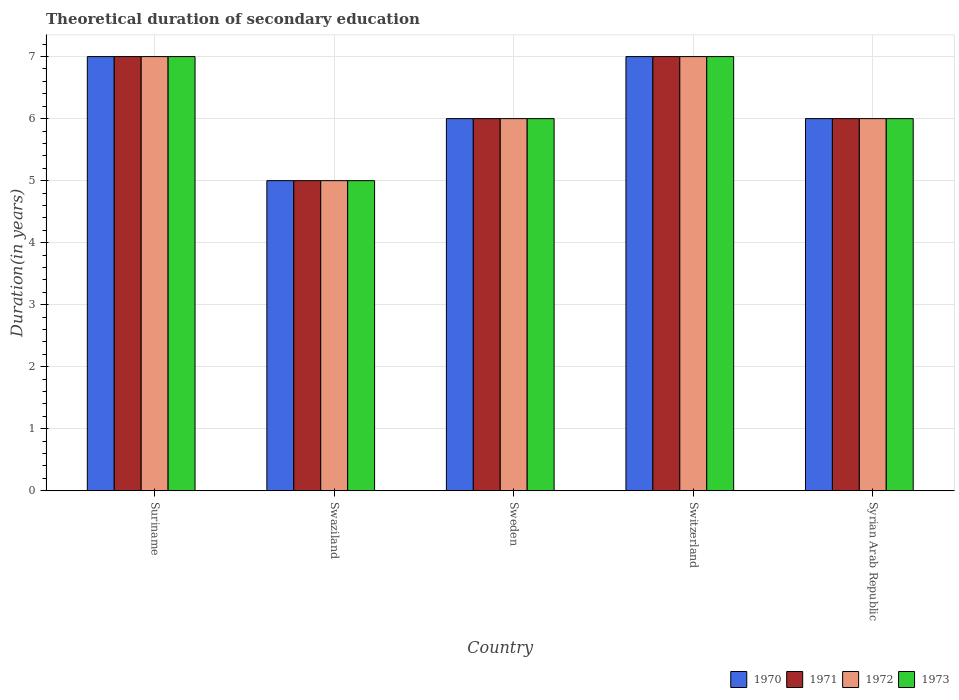How many different coloured bars are there?
Provide a succinct answer. 4. Are the number of bars on each tick of the X-axis equal?
Your response must be concise. Yes. How many bars are there on the 4th tick from the left?
Ensure brevity in your answer.  4. How many bars are there on the 4th tick from the right?
Ensure brevity in your answer.  4. Across all countries, what is the minimum total theoretical duration of secondary education in 1970?
Offer a very short reply. 5. In which country was the total theoretical duration of secondary education in 1970 maximum?
Offer a terse response. Suriname. In which country was the total theoretical duration of secondary education in 1973 minimum?
Your answer should be compact. Swaziland. What is the total total theoretical duration of secondary education in 1973 in the graph?
Provide a succinct answer. 31. What is the average total theoretical duration of secondary education in 1972 per country?
Offer a terse response. 6.2. In how many countries, is the total theoretical duration of secondary education in 1972 greater than 2.4 years?
Offer a terse response. 5. What is the ratio of the total theoretical duration of secondary education in 1971 in Swaziland to that in Sweden?
Provide a succinct answer. 0.83. What is the difference between the highest and the second highest total theoretical duration of secondary education in 1972?
Your answer should be compact. -1. What is the difference between the highest and the lowest total theoretical duration of secondary education in 1972?
Provide a succinct answer. 2. Is the sum of the total theoretical duration of secondary education in 1970 in Sweden and Syrian Arab Republic greater than the maximum total theoretical duration of secondary education in 1972 across all countries?
Ensure brevity in your answer.  Yes. Is it the case that in every country, the sum of the total theoretical duration of secondary education in 1973 and total theoretical duration of secondary education in 1972 is greater than the sum of total theoretical duration of secondary education in 1970 and total theoretical duration of secondary education in 1971?
Ensure brevity in your answer.  No. Are all the bars in the graph horizontal?
Give a very brief answer. No. How many countries are there in the graph?
Make the answer very short. 5. Does the graph contain any zero values?
Your answer should be compact. No. Where does the legend appear in the graph?
Your answer should be very brief. Bottom right. How many legend labels are there?
Ensure brevity in your answer.  4. What is the title of the graph?
Provide a succinct answer. Theoretical duration of secondary education. Does "1973" appear as one of the legend labels in the graph?
Offer a terse response. Yes. What is the label or title of the Y-axis?
Your answer should be very brief. Duration(in years). What is the Duration(in years) of 1971 in Suriname?
Your response must be concise. 7. What is the Duration(in years) in 1972 in Suriname?
Offer a terse response. 7. What is the Duration(in years) of 1973 in Suriname?
Your response must be concise. 7. What is the Duration(in years) in 1970 in Swaziland?
Give a very brief answer. 5. What is the Duration(in years) of 1971 in Swaziland?
Make the answer very short. 5. What is the Duration(in years) of 1970 in Sweden?
Your answer should be compact. 6. What is the Duration(in years) of 1971 in Sweden?
Keep it short and to the point. 6. What is the Duration(in years) in 1973 in Sweden?
Make the answer very short. 6. What is the Duration(in years) in 1970 in Switzerland?
Provide a succinct answer. 7. What is the Duration(in years) in 1971 in Switzerland?
Your response must be concise. 7. What is the Duration(in years) of 1971 in Syrian Arab Republic?
Offer a very short reply. 6. What is the Duration(in years) of 1972 in Syrian Arab Republic?
Your answer should be compact. 6. Across all countries, what is the maximum Duration(in years) of 1970?
Keep it short and to the point. 7. Across all countries, what is the maximum Duration(in years) in 1971?
Ensure brevity in your answer.  7. Across all countries, what is the maximum Duration(in years) in 1972?
Keep it short and to the point. 7. Across all countries, what is the maximum Duration(in years) in 1973?
Your answer should be compact. 7. Across all countries, what is the minimum Duration(in years) in 1970?
Ensure brevity in your answer.  5. What is the total Duration(in years) in 1971 in the graph?
Give a very brief answer. 31. What is the total Duration(in years) in 1973 in the graph?
Give a very brief answer. 31. What is the difference between the Duration(in years) in 1971 in Suriname and that in Swaziland?
Your response must be concise. 2. What is the difference between the Duration(in years) in 1972 in Suriname and that in Swaziland?
Your response must be concise. 2. What is the difference between the Duration(in years) of 1973 in Suriname and that in Swaziland?
Provide a short and direct response. 2. What is the difference between the Duration(in years) of 1970 in Suriname and that in Sweden?
Ensure brevity in your answer.  1. What is the difference between the Duration(in years) in 1972 in Suriname and that in Sweden?
Ensure brevity in your answer.  1. What is the difference between the Duration(in years) in 1973 in Suriname and that in Switzerland?
Provide a short and direct response. 0. What is the difference between the Duration(in years) in 1970 in Suriname and that in Syrian Arab Republic?
Your response must be concise. 1. What is the difference between the Duration(in years) of 1970 in Swaziland and that in Sweden?
Offer a terse response. -1. What is the difference between the Duration(in years) of 1971 in Swaziland and that in Sweden?
Keep it short and to the point. -1. What is the difference between the Duration(in years) of 1972 in Swaziland and that in Sweden?
Give a very brief answer. -1. What is the difference between the Duration(in years) of 1973 in Swaziland and that in Sweden?
Provide a succinct answer. -1. What is the difference between the Duration(in years) of 1970 in Swaziland and that in Switzerland?
Offer a terse response. -2. What is the difference between the Duration(in years) of 1971 in Swaziland and that in Switzerland?
Provide a short and direct response. -2. What is the difference between the Duration(in years) in 1973 in Swaziland and that in Switzerland?
Make the answer very short. -2. What is the difference between the Duration(in years) in 1970 in Swaziland and that in Syrian Arab Republic?
Give a very brief answer. -1. What is the difference between the Duration(in years) of 1972 in Swaziland and that in Syrian Arab Republic?
Keep it short and to the point. -1. What is the difference between the Duration(in years) of 1973 in Swaziland and that in Syrian Arab Republic?
Offer a terse response. -1. What is the difference between the Duration(in years) in 1972 in Sweden and that in Switzerland?
Give a very brief answer. -1. What is the difference between the Duration(in years) of 1971 in Sweden and that in Syrian Arab Republic?
Keep it short and to the point. 0. What is the difference between the Duration(in years) of 1970 in Switzerland and that in Syrian Arab Republic?
Provide a succinct answer. 1. What is the difference between the Duration(in years) in 1971 in Switzerland and that in Syrian Arab Republic?
Provide a short and direct response. 1. What is the difference between the Duration(in years) in 1972 in Switzerland and that in Syrian Arab Republic?
Provide a succinct answer. 1. What is the difference between the Duration(in years) of 1970 in Suriname and the Duration(in years) of 1972 in Swaziland?
Offer a terse response. 2. What is the difference between the Duration(in years) of 1970 in Suriname and the Duration(in years) of 1973 in Swaziland?
Make the answer very short. 2. What is the difference between the Duration(in years) in 1970 in Suriname and the Duration(in years) in 1972 in Sweden?
Your answer should be compact. 1. What is the difference between the Duration(in years) of 1970 in Suriname and the Duration(in years) of 1973 in Sweden?
Your answer should be very brief. 1. What is the difference between the Duration(in years) of 1970 in Suriname and the Duration(in years) of 1972 in Switzerland?
Ensure brevity in your answer.  0. What is the difference between the Duration(in years) of 1971 in Suriname and the Duration(in years) of 1973 in Switzerland?
Provide a short and direct response. 0. What is the difference between the Duration(in years) in 1972 in Suriname and the Duration(in years) in 1973 in Switzerland?
Keep it short and to the point. 0. What is the difference between the Duration(in years) in 1970 in Suriname and the Duration(in years) in 1971 in Syrian Arab Republic?
Offer a very short reply. 1. What is the difference between the Duration(in years) of 1970 in Suriname and the Duration(in years) of 1972 in Syrian Arab Republic?
Provide a succinct answer. 1. What is the difference between the Duration(in years) of 1970 in Suriname and the Duration(in years) of 1973 in Syrian Arab Republic?
Provide a succinct answer. 1. What is the difference between the Duration(in years) in 1970 in Swaziland and the Duration(in years) in 1971 in Sweden?
Make the answer very short. -1. What is the difference between the Duration(in years) of 1970 in Swaziland and the Duration(in years) of 1972 in Sweden?
Offer a terse response. -1. What is the difference between the Duration(in years) in 1971 in Swaziland and the Duration(in years) in 1972 in Sweden?
Your response must be concise. -1. What is the difference between the Duration(in years) of 1970 in Swaziland and the Duration(in years) of 1972 in Switzerland?
Give a very brief answer. -2. What is the difference between the Duration(in years) of 1970 in Swaziland and the Duration(in years) of 1973 in Switzerland?
Ensure brevity in your answer.  -2. What is the difference between the Duration(in years) in 1971 in Swaziland and the Duration(in years) in 1972 in Switzerland?
Give a very brief answer. -2. What is the difference between the Duration(in years) of 1972 in Swaziland and the Duration(in years) of 1973 in Switzerland?
Offer a terse response. -2. What is the difference between the Duration(in years) in 1970 in Swaziland and the Duration(in years) in 1972 in Syrian Arab Republic?
Your answer should be very brief. -1. What is the difference between the Duration(in years) of 1971 in Swaziland and the Duration(in years) of 1973 in Syrian Arab Republic?
Ensure brevity in your answer.  -1. What is the difference between the Duration(in years) in 1972 in Swaziland and the Duration(in years) in 1973 in Syrian Arab Republic?
Your answer should be very brief. -1. What is the difference between the Duration(in years) in 1970 in Sweden and the Duration(in years) in 1972 in Switzerland?
Provide a short and direct response. -1. What is the difference between the Duration(in years) in 1971 in Sweden and the Duration(in years) in 1972 in Switzerland?
Provide a short and direct response. -1. What is the difference between the Duration(in years) in 1970 in Sweden and the Duration(in years) in 1971 in Syrian Arab Republic?
Offer a terse response. 0. What is the difference between the Duration(in years) of 1971 in Sweden and the Duration(in years) of 1972 in Syrian Arab Republic?
Ensure brevity in your answer.  0. What is the difference between the Duration(in years) in 1971 in Sweden and the Duration(in years) in 1973 in Syrian Arab Republic?
Provide a short and direct response. 0. What is the difference between the Duration(in years) in 1972 in Sweden and the Duration(in years) in 1973 in Syrian Arab Republic?
Provide a short and direct response. 0. What is the difference between the Duration(in years) in 1970 in Switzerland and the Duration(in years) in 1973 in Syrian Arab Republic?
Your response must be concise. 1. What is the difference between the Duration(in years) in 1971 in Switzerland and the Duration(in years) in 1972 in Syrian Arab Republic?
Ensure brevity in your answer.  1. What is the difference between the Duration(in years) in 1972 in Switzerland and the Duration(in years) in 1973 in Syrian Arab Republic?
Provide a short and direct response. 1. What is the average Duration(in years) of 1970 per country?
Your answer should be very brief. 6.2. What is the difference between the Duration(in years) in 1970 and Duration(in years) in 1971 in Suriname?
Your answer should be very brief. 0. What is the difference between the Duration(in years) in 1970 and Duration(in years) in 1972 in Suriname?
Your response must be concise. 0. What is the difference between the Duration(in years) in 1971 and Duration(in years) in 1972 in Suriname?
Your answer should be compact. 0. What is the difference between the Duration(in years) of 1970 and Duration(in years) of 1971 in Swaziland?
Your answer should be very brief. 0. What is the difference between the Duration(in years) in 1970 and Duration(in years) in 1973 in Swaziland?
Your answer should be very brief. 0. What is the difference between the Duration(in years) in 1971 and Duration(in years) in 1972 in Swaziland?
Your answer should be compact. 0. What is the difference between the Duration(in years) in 1971 and Duration(in years) in 1973 in Swaziland?
Keep it short and to the point. 0. What is the difference between the Duration(in years) in 1970 and Duration(in years) in 1971 in Sweden?
Give a very brief answer. 0. What is the difference between the Duration(in years) of 1970 and Duration(in years) of 1972 in Sweden?
Keep it short and to the point. 0. What is the difference between the Duration(in years) in 1970 and Duration(in years) in 1973 in Sweden?
Give a very brief answer. 0. What is the difference between the Duration(in years) of 1971 and Duration(in years) of 1972 in Sweden?
Ensure brevity in your answer.  0. What is the difference between the Duration(in years) in 1970 and Duration(in years) in 1973 in Switzerland?
Keep it short and to the point. 0. What is the difference between the Duration(in years) in 1971 and Duration(in years) in 1972 in Switzerland?
Give a very brief answer. 0. What is the difference between the Duration(in years) in 1971 and Duration(in years) in 1973 in Switzerland?
Offer a terse response. 0. What is the difference between the Duration(in years) in 1972 and Duration(in years) in 1973 in Switzerland?
Your answer should be compact. 0. What is the difference between the Duration(in years) in 1970 and Duration(in years) in 1973 in Syrian Arab Republic?
Offer a terse response. 0. What is the difference between the Duration(in years) of 1971 and Duration(in years) of 1972 in Syrian Arab Republic?
Your response must be concise. 0. What is the difference between the Duration(in years) of 1971 and Duration(in years) of 1973 in Syrian Arab Republic?
Provide a succinct answer. 0. What is the difference between the Duration(in years) in 1972 and Duration(in years) in 1973 in Syrian Arab Republic?
Provide a short and direct response. 0. What is the ratio of the Duration(in years) in 1972 in Suriname to that in Swaziland?
Your answer should be compact. 1.4. What is the ratio of the Duration(in years) of 1972 in Suriname to that in Sweden?
Your answer should be very brief. 1.17. What is the ratio of the Duration(in years) of 1973 in Suriname to that in Sweden?
Provide a short and direct response. 1.17. What is the ratio of the Duration(in years) in 1970 in Suriname to that in Switzerland?
Your answer should be compact. 1. What is the ratio of the Duration(in years) of 1970 in Suriname to that in Syrian Arab Republic?
Provide a succinct answer. 1.17. What is the ratio of the Duration(in years) in 1970 in Swaziland to that in Sweden?
Your answer should be compact. 0.83. What is the ratio of the Duration(in years) of 1971 in Swaziland to that in Switzerland?
Ensure brevity in your answer.  0.71. What is the ratio of the Duration(in years) in 1972 in Swaziland to that in Switzerland?
Give a very brief answer. 0.71. What is the ratio of the Duration(in years) in 1970 in Swaziland to that in Syrian Arab Republic?
Your answer should be very brief. 0.83. What is the ratio of the Duration(in years) of 1973 in Swaziland to that in Syrian Arab Republic?
Offer a terse response. 0.83. What is the ratio of the Duration(in years) of 1972 in Sweden to that in Switzerland?
Your answer should be compact. 0.86. What is the ratio of the Duration(in years) of 1973 in Sweden to that in Switzerland?
Keep it short and to the point. 0.86. What is the ratio of the Duration(in years) of 1970 in Sweden to that in Syrian Arab Republic?
Your response must be concise. 1. What is the ratio of the Duration(in years) in 1973 in Sweden to that in Syrian Arab Republic?
Provide a succinct answer. 1. What is the ratio of the Duration(in years) in 1970 in Switzerland to that in Syrian Arab Republic?
Offer a very short reply. 1.17. What is the ratio of the Duration(in years) of 1971 in Switzerland to that in Syrian Arab Republic?
Provide a succinct answer. 1.17. What is the ratio of the Duration(in years) of 1972 in Switzerland to that in Syrian Arab Republic?
Your response must be concise. 1.17. What is the ratio of the Duration(in years) in 1973 in Switzerland to that in Syrian Arab Republic?
Offer a terse response. 1.17. What is the difference between the highest and the second highest Duration(in years) in 1972?
Make the answer very short. 0. What is the difference between the highest and the lowest Duration(in years) in 1970?
Offer a terse response. 2. What is the difference between the highest and the lowest Duration(in years) of 1971?
Keep it short and to the point. 2. What is the difference between the highest and the lowest Duration(in years) of 1972?
Ensure brevity in your answer.  2. 